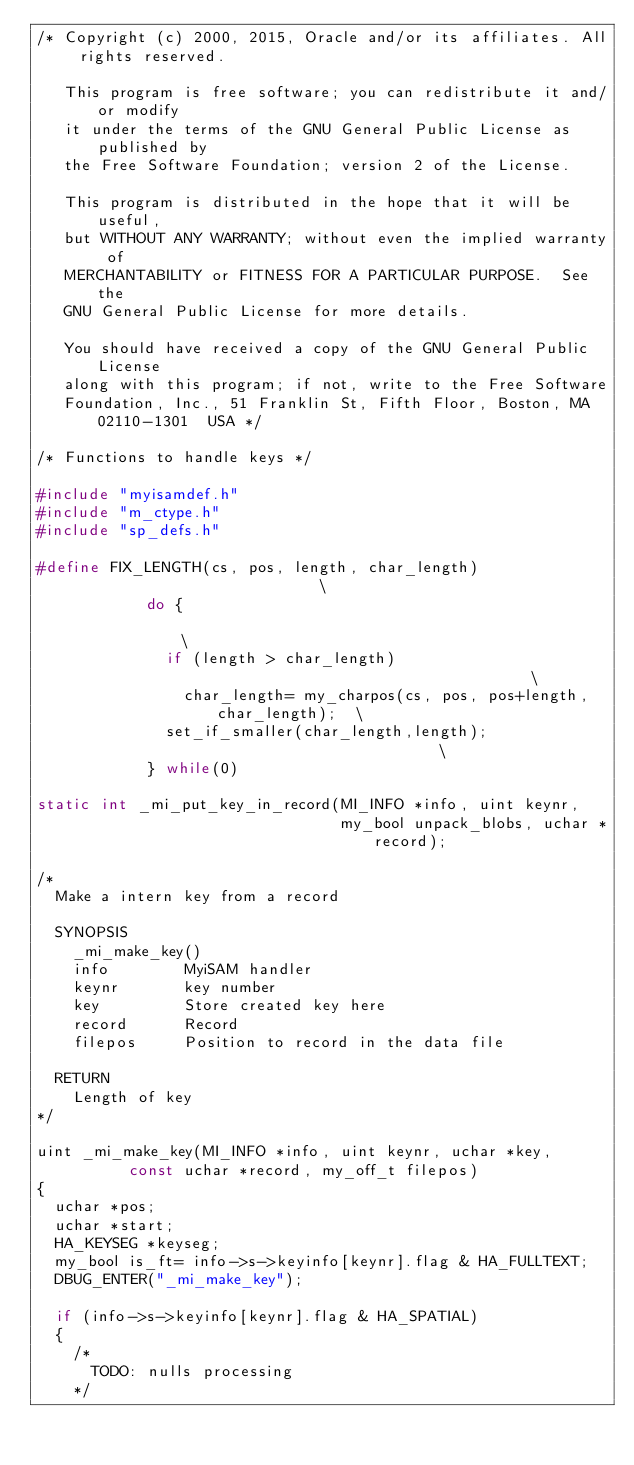Convert code to text. <code><loc_0><loc_0><loc_500><loc_500><_C_>/* Copyright (c) 2000, 2015, Oracle and/or its affiliates. All rights reserved.

   This program is free software; you can redistribute it and/or modify
   it under the terms of the GNU General Public License as published by
   the Free Software Foundation; version 2 of the License.

   This program is distributed in the hope that it will be useful,
   but WITHOUT ANY WARRANTY; without even the implied warranty of
   MERCHANTABILITY or FITNESS FOR A PARTICULAR PURPOSE.  See the
   GNU General Public License for more details.

   You should have received a copy of the GNU General Public License
   along with this program; if not, write to the Free Software
   Foundation, Inc., 51 Franklin St, Fifth Floor, Boston, MA 02110-1301  USA */

/* Functions to handle keys */

#include "myisamdef.h"
#include "m_ctype.h"
#include "sp_defs.h"

#define FIX_LENGTH(cs, pos, length, char_length)                            \
            do {                                                            \
              if (length > char_length)                                     \
                char_length= my_charpos(cs, pos, pos+length, char_length);  \
              set_if_smaller(char_length,length);                           \
            } while(0)

static int _mi_put_key_in_record(MI_INFO *info, uint keynr, 
                                 my_bool unpack_blobs, uchar *record);

/*
  Make a intern key from a record

  SYNOPSIS
    _mi_make_key()
    info		MyiSAM handler
    keynr		key number
    key			Store created key here
    record		Record
    filepos		Position to record in the data file

  RETURN
    Length of key
*/

uint _mi_make_key(MI_INFO *info, uint keynr, uchar *key,
		  const uchar *record, my_off_t filepos)
{
  uchar *pos;
  uchar *start;
  HA_KEYSEG *keyseg;
  my_bool is_ft= info->s->keyinfo[keynr].flag & HA_FULLTEXT;
  DBUG_ENTER("_mi_make_key");

  if (info->s->keyinfo[keynr].flag & HA_SPATIAL)
  {
    /*
      TODO: nulls processing
    */</code> 